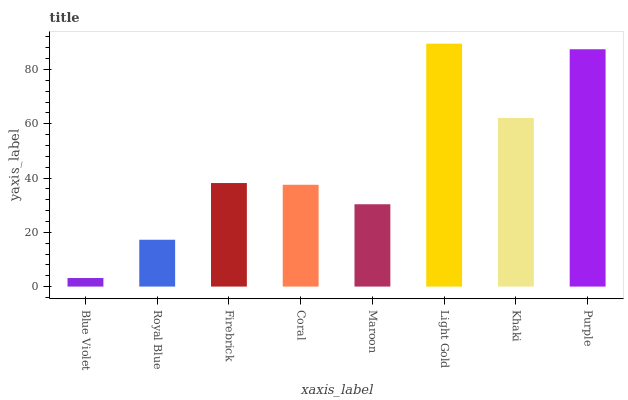Is Blue Violet the minimum?
Answer yes or no. Yes. Is Light Gold the maximum?
Answer yes or no. Yes. Is Royal Blue the minimum?
Answer yes or no. No. Is Royal Blue the maximum?
Answer yes or no. No. Is Royal Blue greater than Blue Violet?
Answer yes or no. Yes. Is Blue Violet less than Royal Blue?
Answer yes or no. Yes. Is Blue Violet greater than Royal Blue?
Answer yes or no. No. Is Royal Blue less than Blue Violet?
Answer yes or no. No. Is Firebrick the high median?
Answer yes or no. Yes. Is Coral the low median?
Answer yes or no. Yes. Is Maroon the high median?
Answer yes or no. No. Is Light Gold the low median?
Answer yes or no. No. 